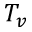<formula> <loc_0><loc_0><loc_500><loc_500>T _ { v }</formula> 